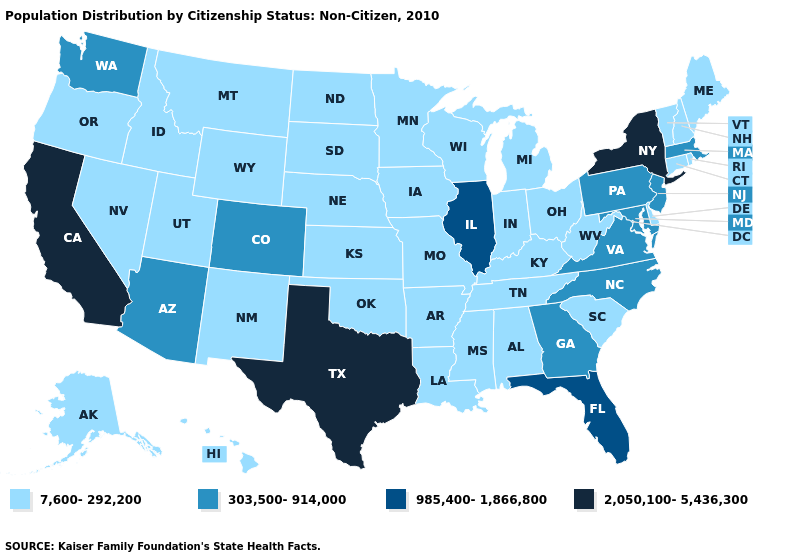Name the states that have a value in the range 985,400-1,866,800?
Give a very brief answer. Florida, Illinois. Among the states that border Idaho , does Washington have the highest value?
Be succinct. Yes. Which states hav the highest value in the South?
Be succinct. Texas. What is the value of New Mexico?
Keep it brief. 7,600-292,200. What is the value of Arizona?
Be succinct. 303,500-914,000. What is the value of Washington?
Quick response, please. 303,500-914,000. Which states have the highest value in the USA?
Concise answer only. California, New York, Texas. How many symbols are there in the legend?
Give a very brief answer. 4. Does Georgia have the lowest value in the USA?
Be succinct. No. What is the value of Wyoming?
Quick response, please. 7,600-292,200. What is the value of Virginia?
Short answer required. 303,500-914,000. Name the states that have a value in the range 985,400-1,866,800?
Be succinct. Florida, Illinois. Does the first symbol in the legend represent the smallest category?
Answer briefly. Yes. Which states hav the highest value in the South?
Be succinct. Texas. What is the value of North Dakota?
Write a very short answer. 7,600-292,200. 